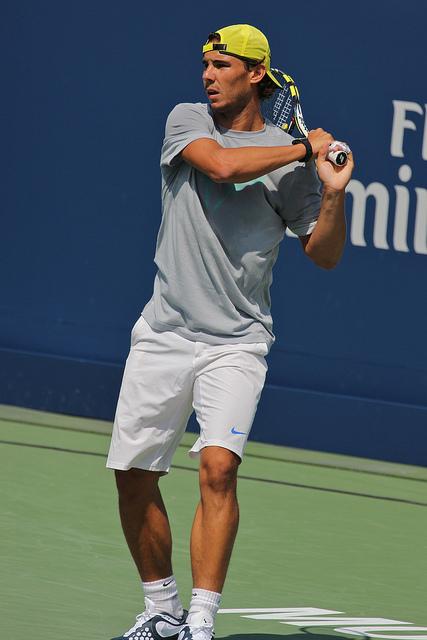What brand of socks is the man wearing?
Quick response, please. Nike. What is the man playing?
Write a very short answer. Tennis. What color are the man's shorts?
Keep it brief. White. Where is the NIKE logo?
Concise answer only. Shorts. What brand of sneakers is he wearing?
Concise answer only. Nike. What color is the man's hat?
Quick response, please. Yellow. Is the tennis play male or female?
Concise answer only. Male. Is the man tan?
Give a very brief answer. Yes. What color is the racket?
Give a very brief answer. White. 